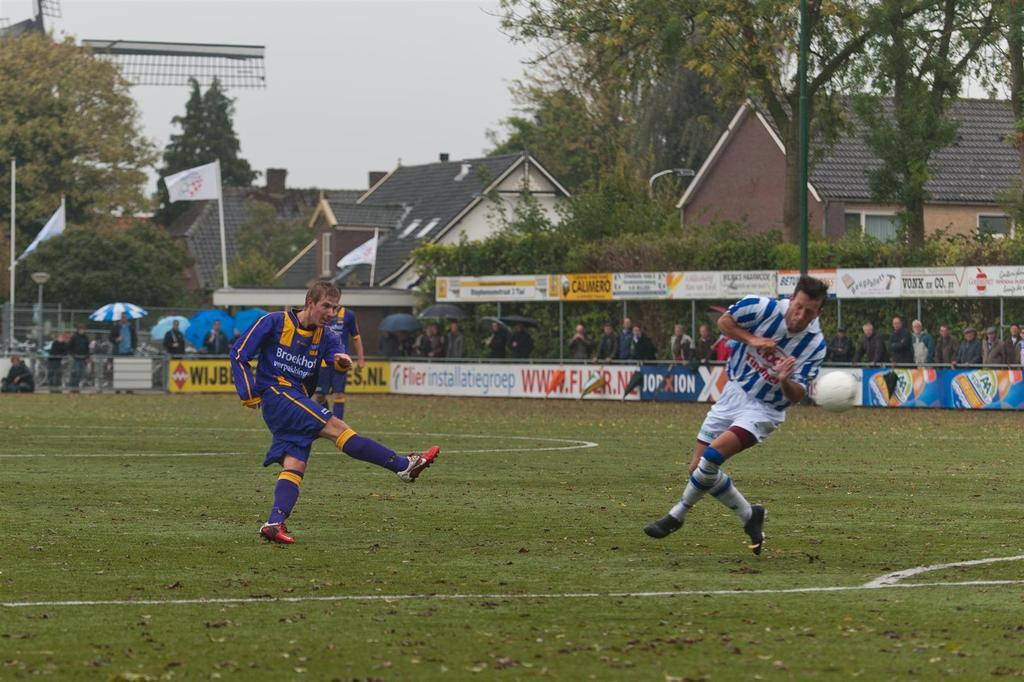Provide a one-sentence caption for the provided image. Two young men go head to head in a youth soccer game. 